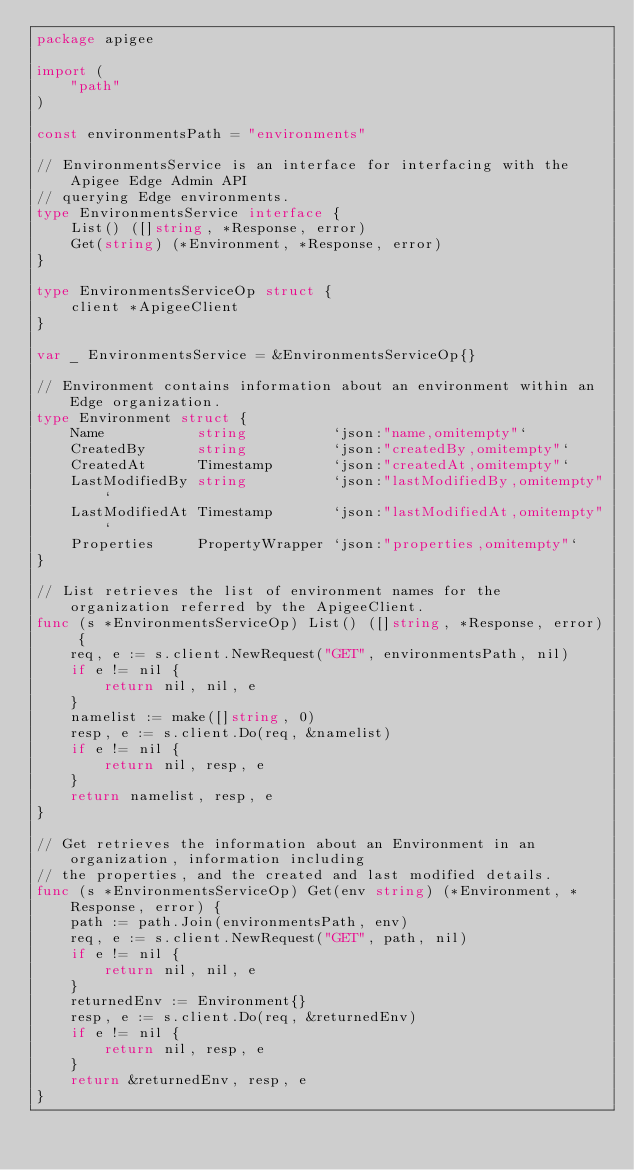Convert code to text. <code><loc_0><loc_0><loc_500><loc_500><_Go_>package apigee

import (
	"path"
)

const environmentsPath = "environments"

// EnvironmentsService is an interface for interfacing with the Apigee Edge Admin API
// querying Edge environments.
type EnvironmentsService interface {
	List() ([]string, *Response, error)
	Get(string) (*Environment, *Response, error)
}

type EnvironmentsServiceOp struct {
	client *ApigeeClient
}

var _ EnvironmentsService = &EnvironmentsServiceOp{}

// Environment contains information about an environment within an Edge organization.
type Environment struct {
	Name           string          `json:"name,omitempty"`
	CreatedBy      string          `json:"createdBy,omitempty"`
	CreatedAt      Timestamp       `json:"createdAt,omitempty"`
	LastModifiedBy string          `json:"lastModifiedBy,omitempty"`
	LastModifiedAt Timestamp       `json:"lastModifiedAt,omitempty"`
	Properties     PropertyWrapper `json:"properties,omitempty"`
}

// List retrieves the list of environment names for the organization referred by the ApigeeClient.
func (s *EnvironmentsServiceOp) List() ([]string, *Response, error) {
	req, e := s.client.NewRequest("GET", environmentsPath, nil)
	if e != nil {
		return nil, nil, e
	}
	namelist := make([]string, 0)
	resp, e := s.client.Do(req, &namelist)
	if e != nil {
		return nil, resp, e
	}
	return namelist, resp, e
}

// Get retrieves the information about an Environment in an organization, information including
// the properties, and the created and last modified details.
func (s *EnvironmentsServiceOp) Get(env string) (*Environment, *Response, error) {
	path := path.Join(environmentsPath, env)
	req, e := s.client.NewRequest("GET", path, nil)
	if e != nil {
		return nil, nil, e
	}
	returnedEnv := Environment{}
	resp, e := s.client.Do(req, &returnedEnv)
	if e != nil {
		return nil, resp, e
	}
	return &returnedEnv, resp, e
}
</code> 